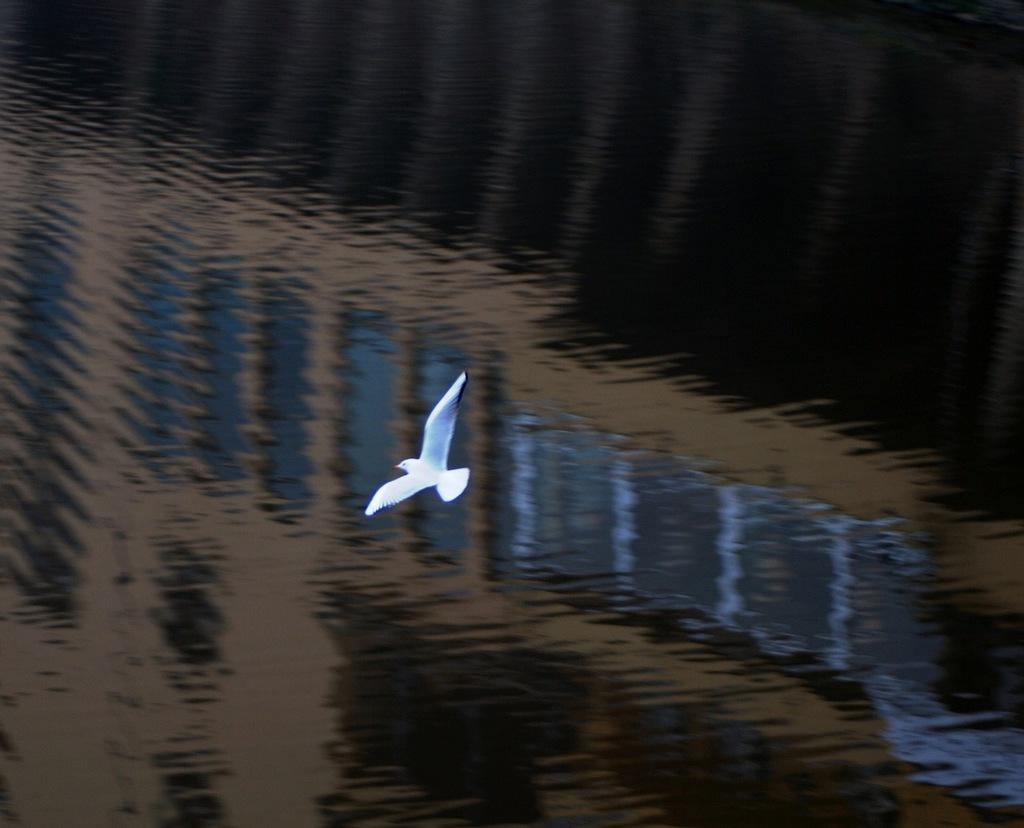What type of bird is in the image? There is a pigeon in the image. What color is the pigeon? The pigeon is white. What is the pigeon doing in the image? The pigeon is flying in the air. What can be seen at the bottom of the image? There is water visible at the bottom of the image. What type of linen is draped over the curtain in the image? There is no linen or curtain present in the image; it features a white pigeon flying in the air with water visible at the bottom. 